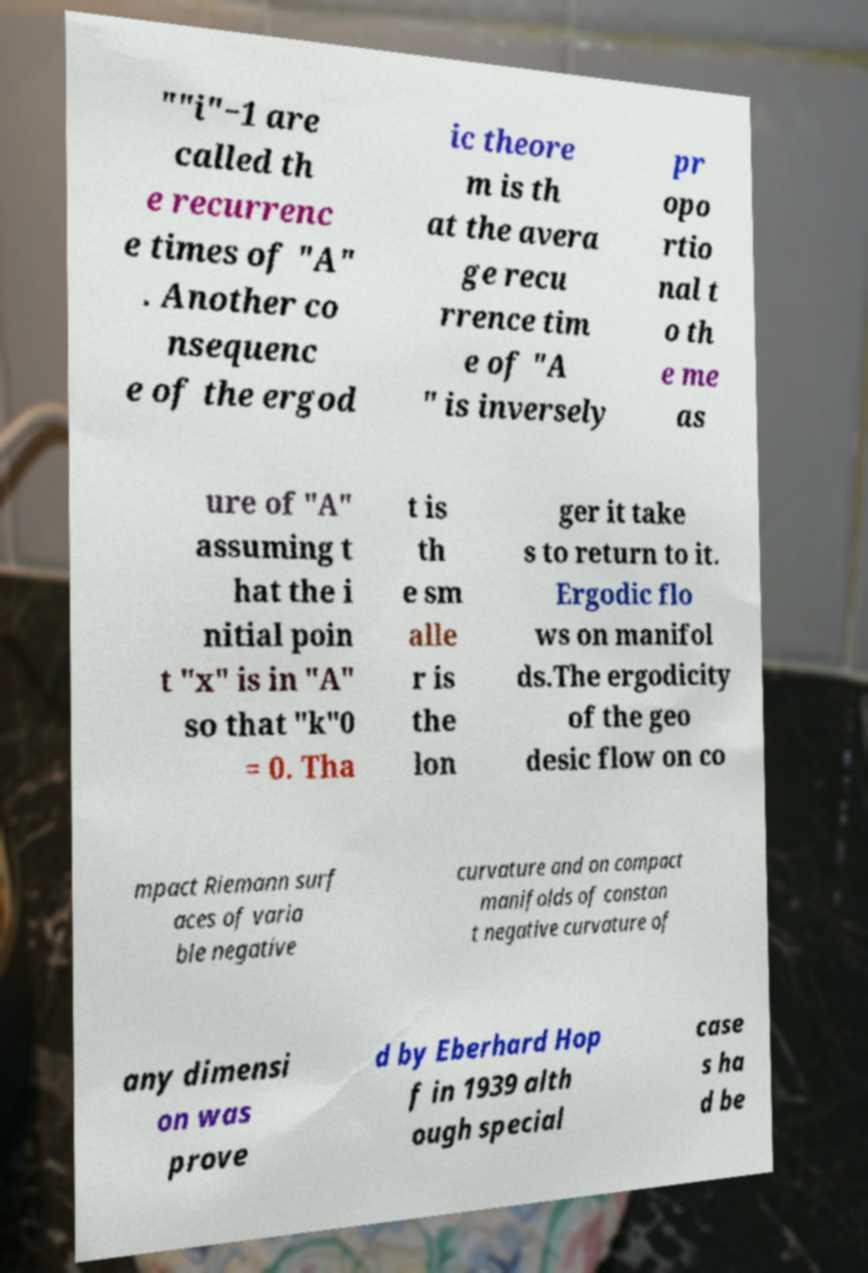I need the written content from this picture converted into text. Can you do that? ""i"−1 are called th e recurrenc e times of "A" . Another co nsequenc e of the ergod ic theore m is th at the avera ge recu rrence tim e of "A " is inversely pr opo rtio nal t o th e me as ure of "A" assuming t hat the i nitial poin t "x" is in "A" so that "k"0 = 0. Tha t is th e sm alle r is the lon ger it take s to return to it. Ergodic flo ws on manifol ds.The ergodicity of the geo desic flow on co mpact Riemann surf aces of varia ble negative curvature and on compact manifolds of constan t negative curvature of any dimensi on was prove d by Eberhard Hop f in 1939 alth ough special case s ha d be 